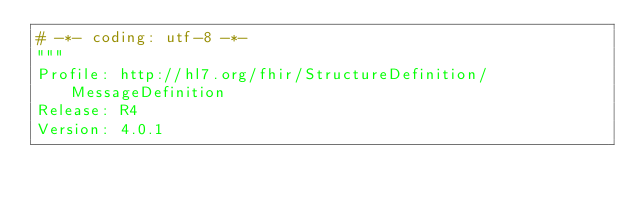Convert code to text. <code><loc_0><loc_0><loc_500><loc_500><_Python_># -*- coding: utf-8 -*-
"""
Profile: http://hl7.org/fhir/StructureDefinition/MessageDefinition
Release: R4
Version: 4.0.1</code> 